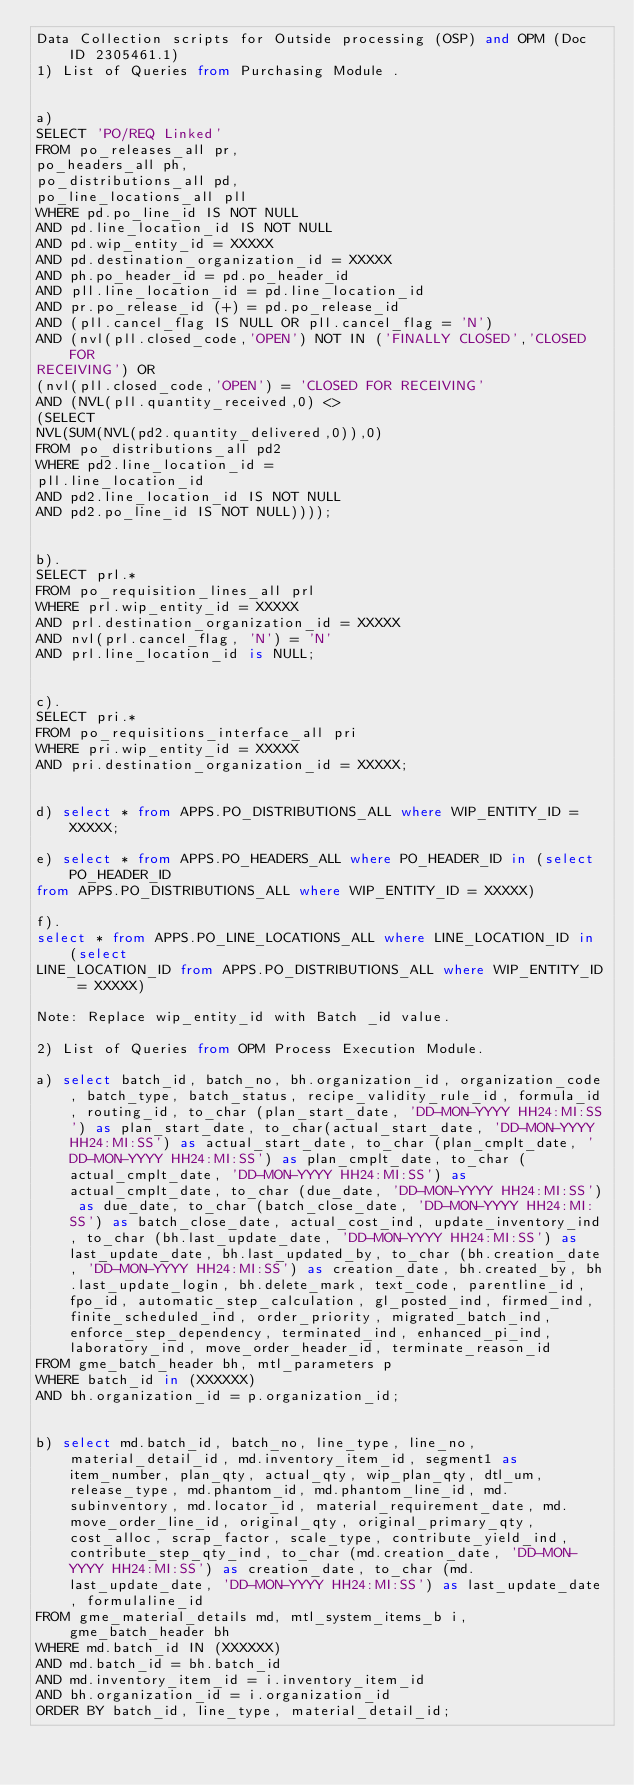Convert code to text. <code><loc_0><loc_0><loc_500><loc_500><_SQL_>Data Collection scripts for Outside processing (OSP) and OPM (Doc ID 2305461.1)
1) List of Queries from Purchasing Module .


a)
SELECT 'PO/REQ Linked'
FROM po_releases_all pr,
po_headers_all ph,
po_distributions_all pd,
po_line_locations_all pll
WHERE pd.po_line_id IS NOT NULL
AND pd.line_location_id IS NOT NULL
AND pd.wip_entity_id = XXXXX
AND pd.destination_organization_id = XXXXX
AND ph.po_header_id = pd.po_header_id
AND pll.line_location_id = pd.line_location_id
AND pr.po_release_id (+) = pd.po_release_id
AND (pll.cancel_flag IS NULL OR pll.cancel_flag = 'N')
AND (nvl(pll.closed_code,'OPEN') NOT IN ('FINALLY CLOSED','CLOSED FOR
RECEIVING') OR
(nvl(pll.closed_code,'OPEN') = 'CLOSED FOR RECEIVING'
AND (NVL(pll.quantity_received,0) <>
(SELECT
NVL(SUM(NVL(pd2.quantity_delivered,0)),0)
FROM po_distributions_all pd2
WHERE pd2.line_location_id =
pll.line_location_id
AND pd2.line_location_id IS NOT NULL
AND pd2.po_line_id IS NOT NULL))));


b).
SELECT prl.*
FROM po_requisition_lines_all prl
WHERE prl.wip_entity_id = XXXXX
AND prl.destination_organization_id = XXXXX
AND nvl(prl.cancel_flag, 'N') = 'N'
AND prl.line_location_id is NULL;


c).
SELECT pri.*
FROM po_requisitions_interface_all pri
WHERE pri.wip_entity_id = XXXXX
AND pri.destination_organization_id = XXXXX;


d) select * from APPS.PO_DISTRIBUTIONS_ALL where WIP_ENTITY_ID = XXXXX;

e) select * from APPS.PO_HEADERS_ALL where PO_HEADER_ID in (select PO_HEADER_ID
from APPS.PO_DISTRIBUTIONS_ALL where WIP_ENTITY_ID = XXXXX)

f).
select * from APPS.PO_LINE_LOCATIONS_ALL where LINE_LOCATION_ID in (select
LINE_LOCATION_ID from APPS.PO_DISTRIBUTIONS_ALL where WIP_ENTITY_ID = XXXXX)

Note: Replace wip_entity_id with Batch _id value.

2) List of Queries from OPM Process Execution Module.

a) select batch_id, batch_no, bh.organization_id, organization_code, batch_type, batch_status, recipe_validity_rule_id, formula_id, routing_id, to_char (plan_start_date, 'DD-MON-YYYY HH24:MI:SS') as plan_start_date, to_char(actual_start_date, 'DD-MON-YYYY HH24:MI:SS') as actual_start_date, to_char (plan_cmplt_date, 'DD-MON-YYYY HH24:MI:SS') as plan_cmplt_date, to_char (actual_cmplt_date, 'DD-MON-YYYY HH24:MI:SS') as actual_cmplt_date, to_char (due_date, 'DD-MON-YYYY HH24:MI:SS') as due_date, to_char (batch_close_date, 'DD-MON-YYYY HH24:MI:SS') as batch_close_date, actual_cost_ind, update_inventory_ind, to_char (bh.last_update_date, 'DD-MON-YYYY HH24:MI:SS') as last_update_date, bh.last_updated_by, to_char (bh.creation_date, 'DD-MON-YYYY HH24:MI:SS') as creation_date, bh.created_by, bh.last_update_login, bh.delete_mark, text_code, parentline_id, fpo_id, automatic_step_calculation, gl_posted_ind, firmed_ind, finite_scheduled_ind, order_priority, migrated_batch_ind, enforce_step_dependency, terminated_ind, enhanced_pi_ind, laboratory_ind, move_order_header_id, terminate_reason_id
FROM gme_batch_header bh, mtl_parameters p
WHERE batch_id in (XXXXXX)
AND bh.organization_id = p.organization_id;


b) select md.batch_id, batch_no, line_type, line_no, material_detail_id, md.inventory_item_id, segment1 as item_number, plan_qty, actual_qty, wip_plan_qty, dtl_um, release_type, md.phantom_id, md.phantom_line_id, md.subinventory, md.locator_id, material_requirement_date, md.move_order_line_id, original_qty, original_primary_qty, cost_alloc, scrap_factor, scale_type, contribute_yield_ind, contribute_step_qty_ind, to_char (md.creation_date, 'DD-MON-YYYY HH24:MI:SS') as creation_date, to_char (md.last_update_date, 'DD-MON-YYYY HH24:MI:SS') as last_update_date, formulaline_id
FROM gme_material_details md, mtl_system_items_b i, gme_batch_header bh
WHERE md.batch_id IN (XXXXXX)
AND md.batch_id = bh.batch_id
AND md.inventory_item_id = i.inventory_item_id
AND bh.organization_id = i.organization_id
ORDER BY batch_id, line_type, material_detail_id;

</code> 